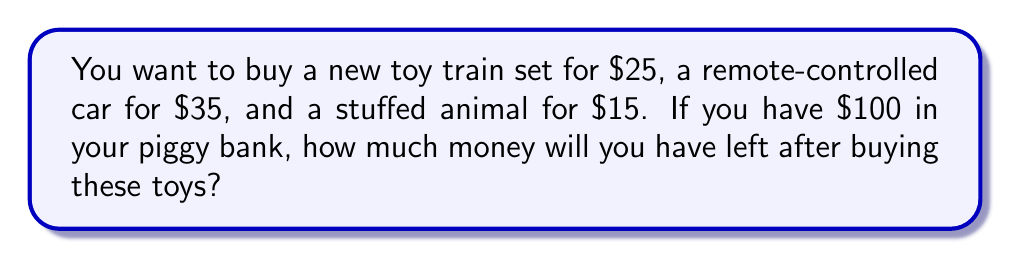Provide a solution to this math problem. Let's solve this problem step by step:

1) First, we need to calculate the total cost of the toys:
   $$ \text{Toy train set} + \text{Remote-controlled car} + \text{Stuffed animal} $$
   $$ 25 + 35 + 15 = 75 $$

2) Now we know that the total cost of the toys is $75.

3) We're given that you have $100 in your piggy bank.

4) To find out how much money is left, we subtract the cost of the toys from the money in the piggy bank:
   $$ \text{Money left} = \text{Money in piggy bank} - \text{Cost of toys} $$
   $$ 100 - 75 = 25 $$

Therefore, you will have $25 left after buying these toys.
Answer: $25 